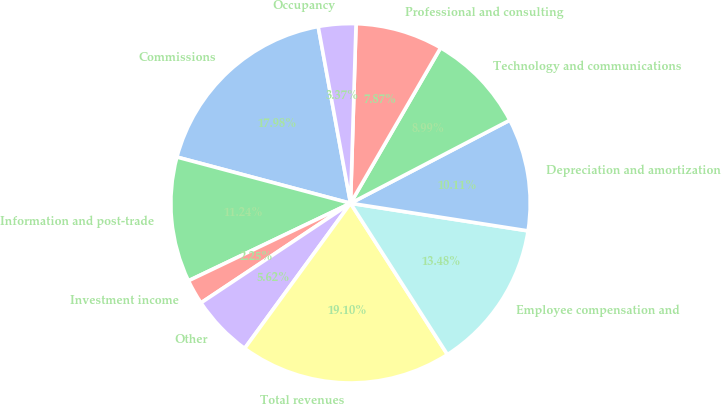<chart> <loc_0><loc_0><loc_500><loc_500><pie_chart><fcel>Commissions<fcel>Information and post-trade<fcel>Investment income<fcel>Other<fcel>Total revenues<fcel>Employee compensation and<fcel>Depreciation and amortization<fcel>Technology and communications<fcel>Professional and consulting<fcel>Occupancy<nl><fcel>17.98%<fcel>11.24%<fcel>2.25%<fcel>5.62%<fcel>19.1%<fcel>13.48%<fcel>10.11%<fcel>8.99%<fcel>7.87%<fcel>3.37%<nl></chart> 